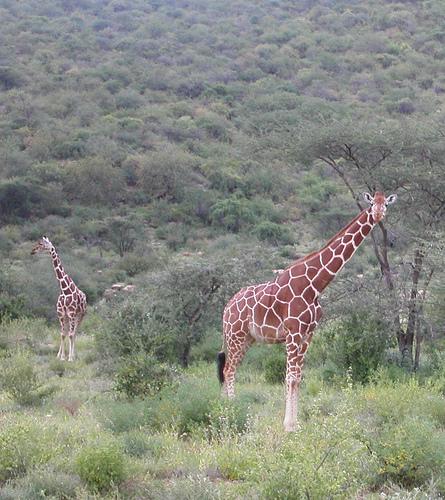What is the hillside covered with?
Short answer required. Trees. Where are the animals in the photograph?
Be succinct. Giraffe. Which giraffe is closest?
Give a very brief answer. Right. Is the giraffe enclosed in a pen?
Write a very short answer. No. How many giraffes are there?
Concise answer only. 2. Are these giraffes aware that there is a such thing as the Internet?
Short answer required. No. 